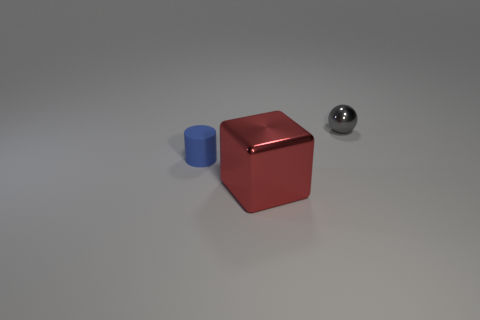Do the gray metallic object and the red metal object have the same size?
Keep it short and to the point. No. What shape is the metal thing in front of the object behind the small object in front of the tiny shiny object?
Make the answer very short. Cube. There is a object that is both right of the tiny cylinder and in front of the tiny gray thing; what is its size?
Offer a very short reply. Large. How many tiny blue objects are in front of the tiny object behind the tiny thing that is in front of the gray sphere?
Ensure brevity in your answer.  1. How many small things are either yellow objects or cylinders?
Make the answer very short. 1. Do the tiny thing that is left of the red block and the gray thing have the same material?
Ensure brevity in your answer.  No. What material is the tiny object that is on the left side of the shiny thing in front of the small object that is behind the tiny blue object?
Provide a short and direct response. Rubber. Is there anything else that is the same size as the cube?
Keep it short and to the point. No. How many shiny things are tiny red spheres or red blocks?
Your answer should be very brief. 1. Are any objects visible?
Your answer should be compact. Yes. 